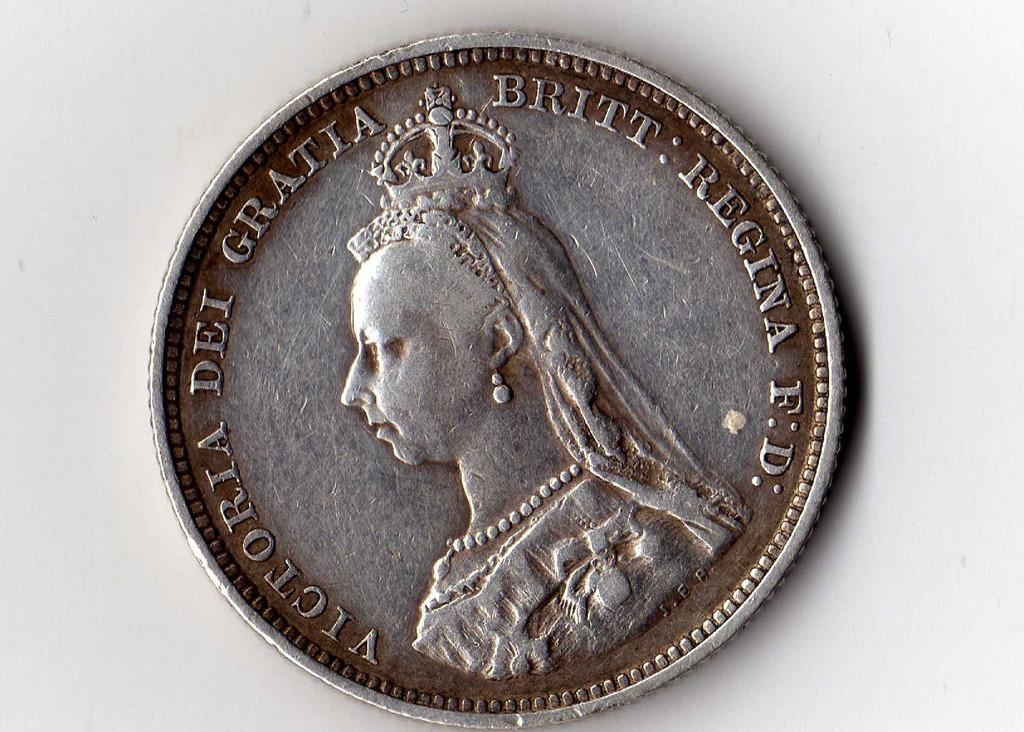Provide a one-sentence caption for the provided image. The old silver coin shown here has a picture and writing of Victoria. 